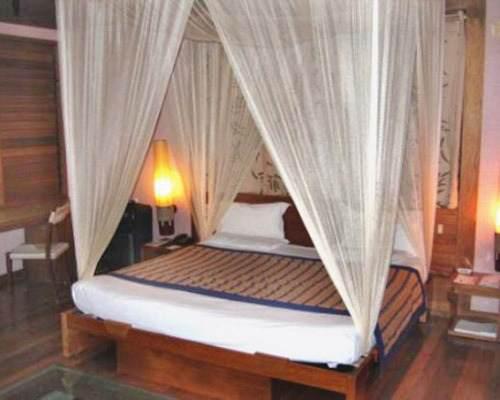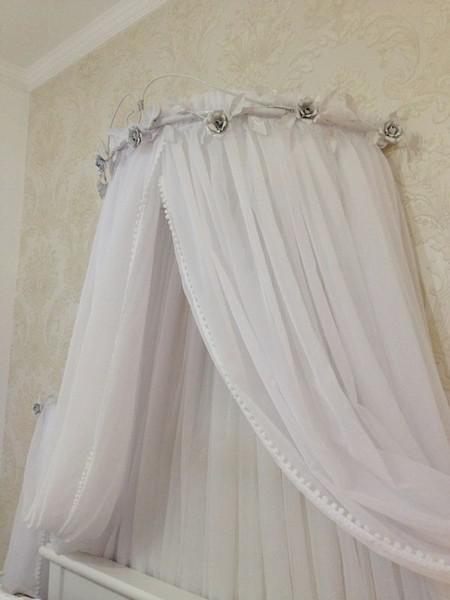The first image is the image on the left, the second image is the image on the right. Evaluate the accuracy of this statement regarding the images: "One of the images of mosquito nets has a round top with silver flowers on it.". Is it true? Answer yes or no. Yes. The first image is the image on the left, the second image is the image on the right. Analyze the images presented: Is the assertion "The style and shape of bed netting is the same in both images." valid? Answer yes or no. No. 